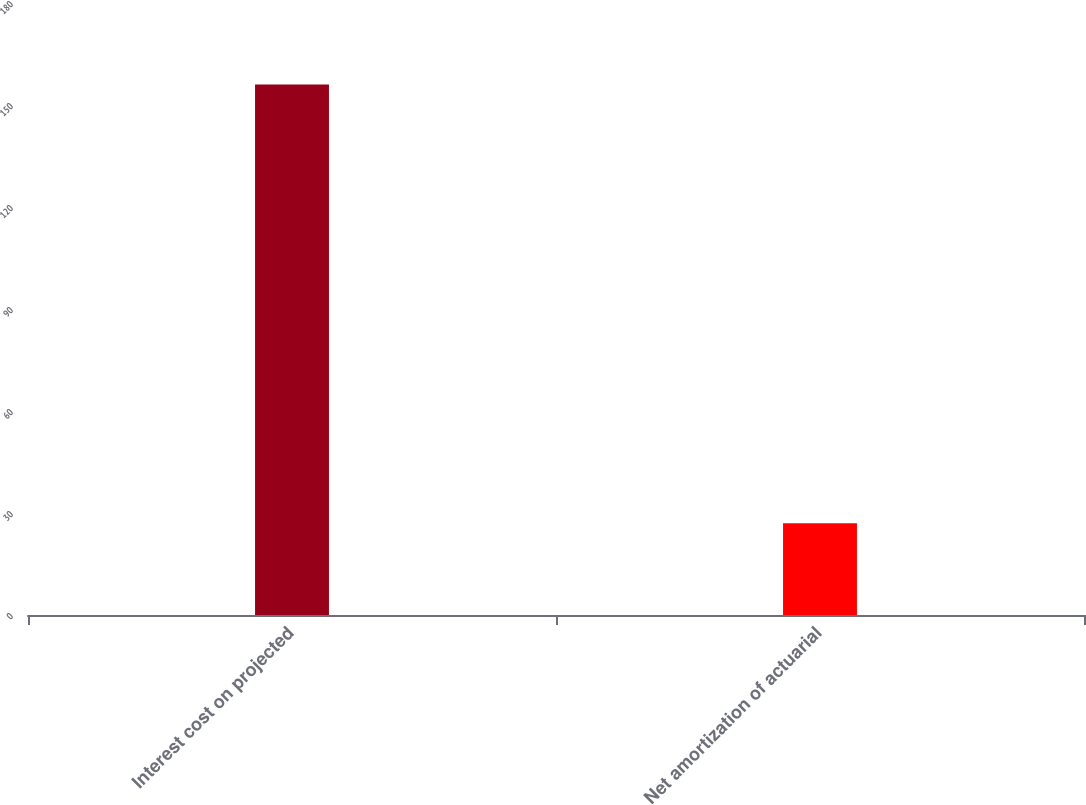Convert chart. <chart><loc_0><loc_0><loc_500><loc_500><bar_chart><fcel>Interest cost on projected<fcel>Net amortization of actuarial<nl><fcel>156<fcel>27<nl></chart> 